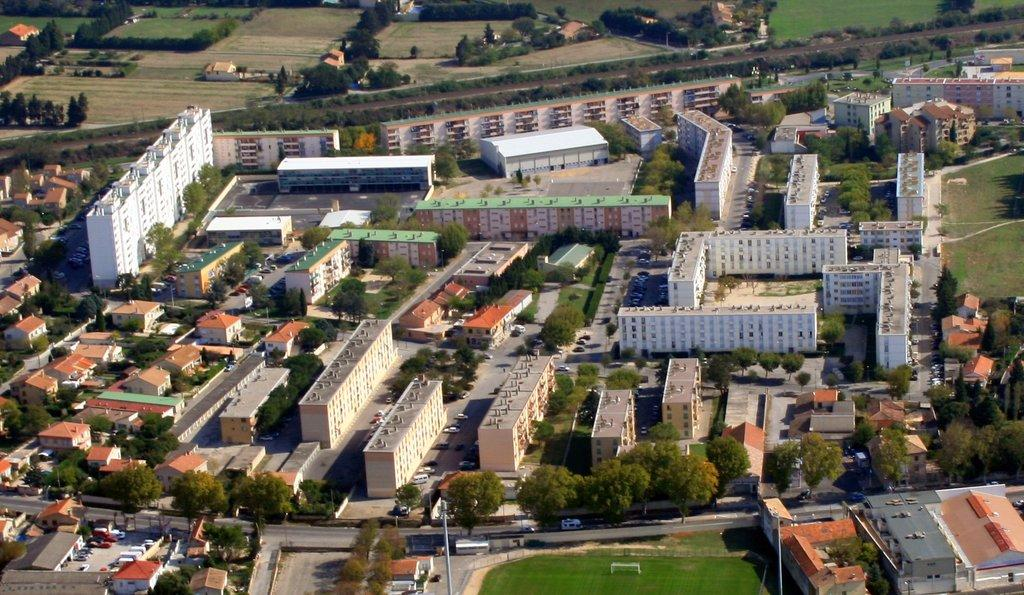What is the main focus of the image? The main focus of the image is the buildings in the center. What else can be seen in the image besides the buildings? There is a road and many trees in the image. What type of needle can be seen in the image? There is no needle present in the image. How is the salt being used in the image? There is no salt present in the image. 